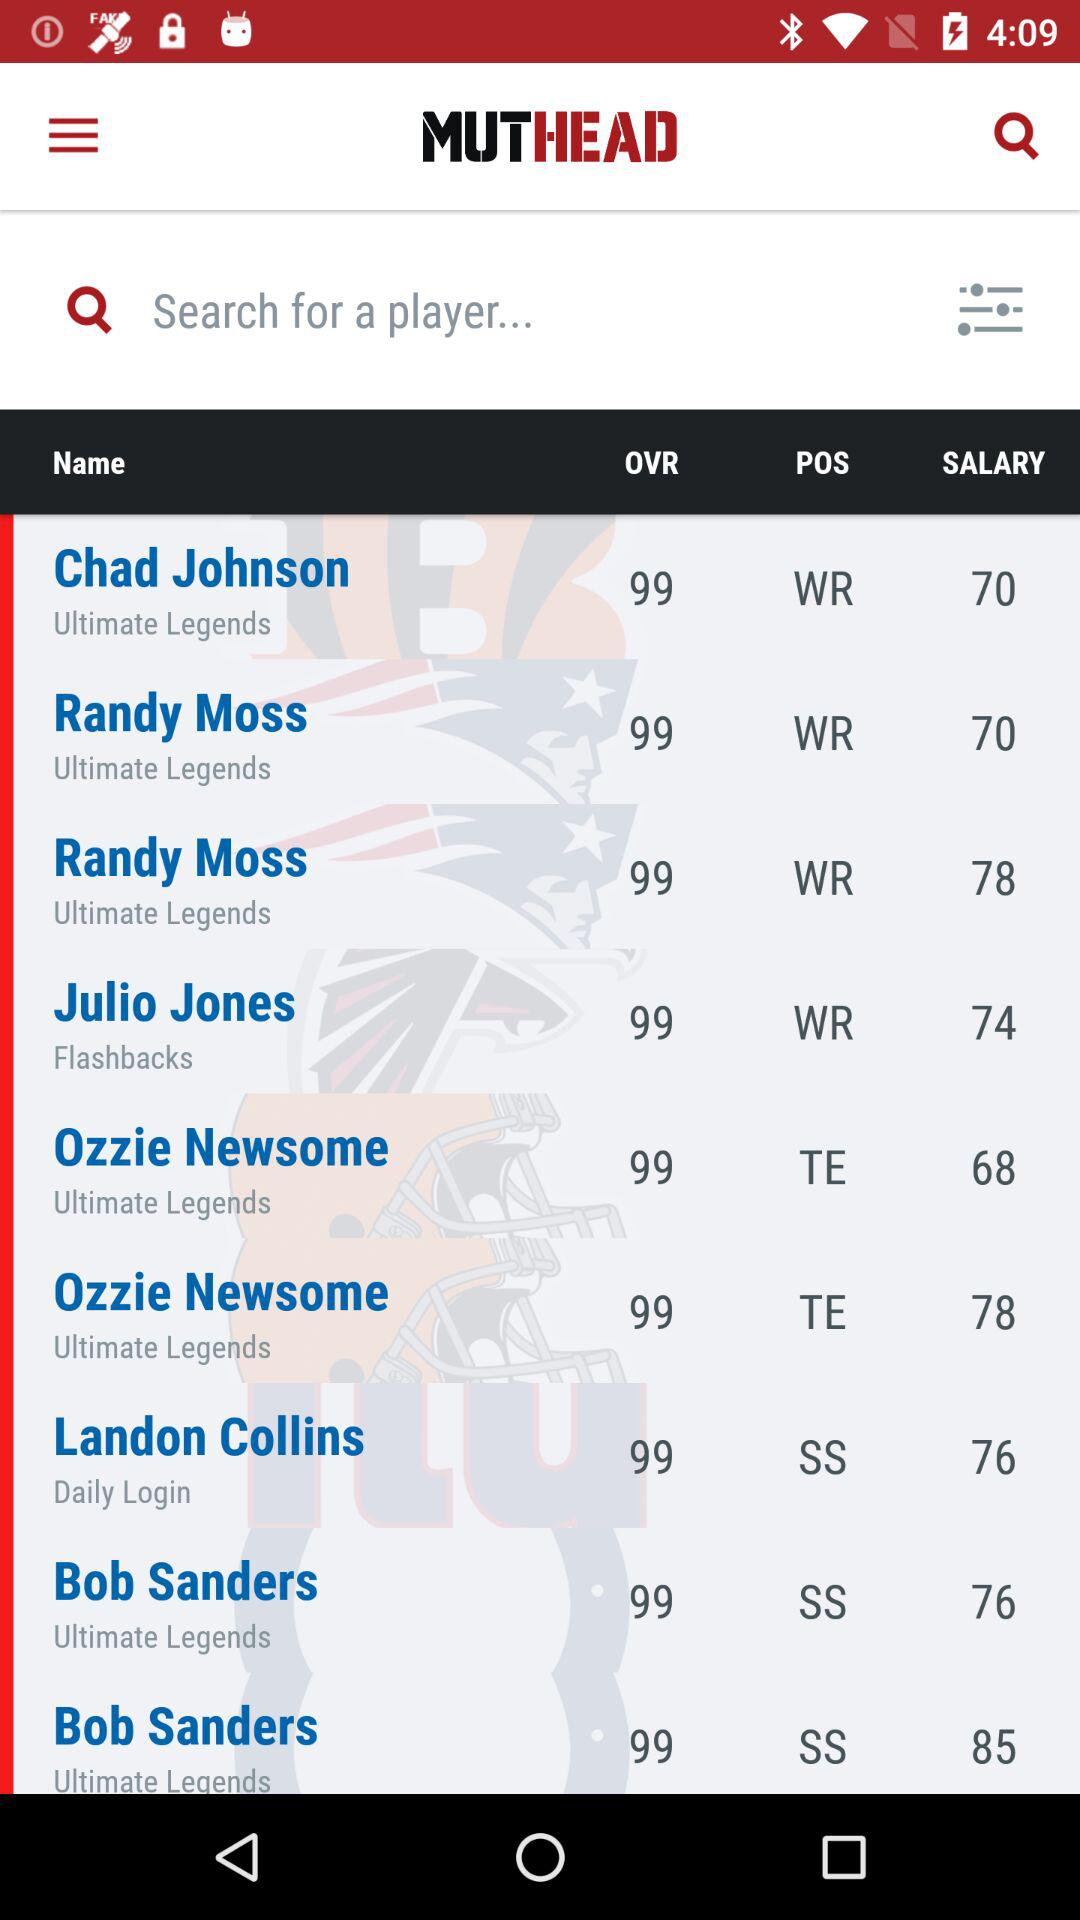What is the overall rating of Chad Johnson? The overall rating is 99. 